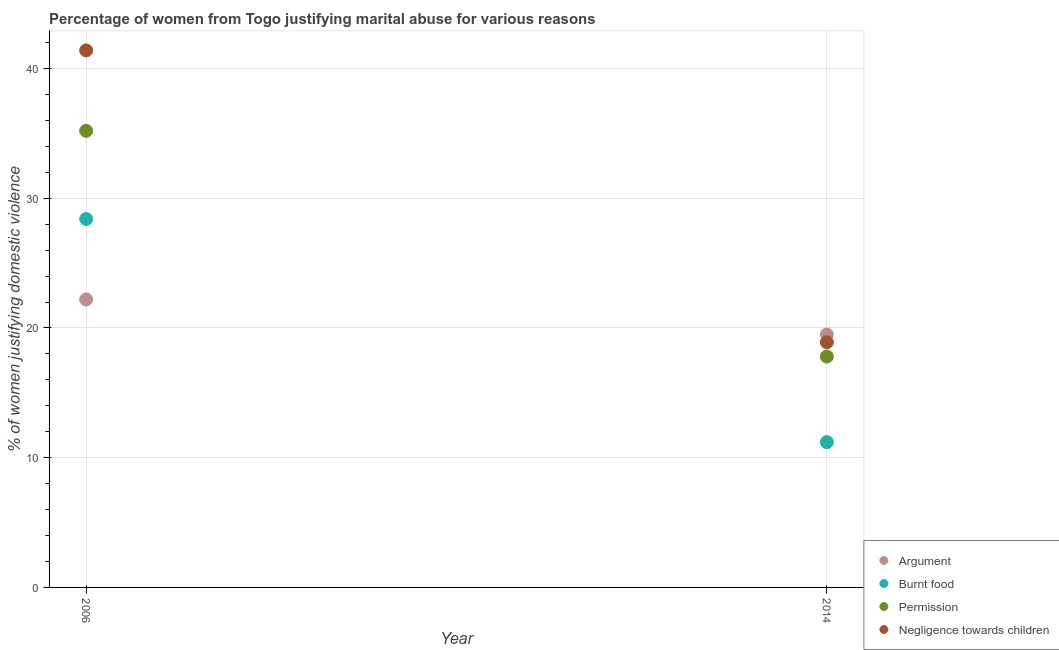How many different coloured dotlines are there?
Keep it short and to the point. 4. Is the number of dotlines equal to the number of legend labels?
Your answer should be very brief. Yes. Across all years, what is the minimum percentage of women justifying abuse for burning food?
Offer a terse response. 11.2. In which year was the percentage of women justifying abuse for burning food maximum?
Offer a terse response. 2006. What is the total percentage of women justifying abuse for burning food in the graph?
Offer a very short reply. 39.6. What is the difference between the percentage of women justifying abuse for burning food in 2006 and the percentage of women justifying abuse for showing negligence towards children in 2014?
Give a very brief answer. 9.5. What is the average percentage of women justifying abuse for burning food per year?
Your answer should be very brief. 19.8. In the year 2014, what is the difference between the percentage of women justifying abuse for going without permission and percentage of women justifying abuse for showing negligence towards children?
Offer a terse response. -1.1. In how many years, is the percentage of women justifying abuse for burning food greater than 6 %?
Provide a short and direct response. 2. What is the ratio of the percentage of women justifying abuse for showing negligence towards children in 2006 to that in 2014?
Your answer should be compact. 2.19. Is the percentage of women justifying abuse for showing negligence towards children in 2006 less than that in 2014?
Your response must be concise. No. In how many years, is the percentage of women justifying abuse for going without permission greater than the average percentage of women justifying abuse for going without permission taken over all years?
Your answer should be very brief. 1. Is it the case that in every year, the sum of the percentage of women justifying abuse in the case of an argument and percentage of women justifying abuse for burning food is greater than the percentage of women justifying abuse for going without permission?
Provide a short and direct response. Yes. Does the percentage of women justifying abuse for showing negligence towards children monotonically increase over the years?
Provide a succinct answer. No. Is the percentage of women justifying abuse for going without permission strictly greater than the percentage of women justifying abuse in the case of an argument over the years?
Keep it short and to the point. No. Is the percentage of women justifying abuse for burning food strictly less than the percentage of women justifying abuse in the case of an argument over the years?
Provide a succinct answer. No. How are the legend labels stacked?
Provide a short and direct response. Vertical. What is the title of the graph?
Provide a short and direct response. Percentage of women from Togo justifying marital abuse for various reasons. What is the label or title of the X-axis?
Offer a very short reply. Year. What is the label or title of the Y-axis?
Provide a succinct answer. % of women justifying domestic violence. What is the % of women justifying domestic violence in Argument in 2006?
Keep it short and to the point. 22.2. What is the % of women justifying domestic violence of Burnt food in 2006?
Provide a short and direct response. 28.4. What is the % of women justifying domestic violence of Permission in 2006?
Make the answer very short. 35.2. What is the % of women justifying domestic violence of Negligence towards children in 2006?
Offer a very short reply. 41.4. What is the % of women justifying domestic violence of Permission in 2014?
Your answer should be compact. 17.8. Across all years, what is the maximum % of women justifying domestic violence of Argument?
Give a very brief answer. 22.2. Across all years, what is the maximum % of women justifying domestic violence in Burnt food?
Make the answer very short. 28.4. Across all years, what is the maximum % of women justifying domestic violence of Permission?
Offer a very short reply. 35.2. Across all years, what is the maximum % of women justifying domestic violence in Negligence towards children?
Give a very brief answer. 41.4. Across all years, what is the minimum % of women justifying domestic violence of Permission?
Provide a short and direct response. 17.8. What is the total % of women justifying domestic violence of Argument in the graph?
Your answer should be compact. 41.7. What is the total % of women justifying domestic violence of Burnt food in the graph?
Provide a short and direct response. 39.6. What is the total % of women justifying domestic violence in Negligence towards children in the graph?
Keep it short and to the point. 60.3. What is the difference between the % of women justifying domestic violence of Burnt food in 2006 and that in 2014?
Provide a short and direct response. 17.2. What is the difference between the % of women justifying domestic violence of Permission in 2006 and that in 2014?
Offer a terse response. 17.4. What is the difference between the % of women justifying domestic violence of Negligence towards children in 2006 and that in 2014?
Your answer should be compact. 22.5. What is the difference between the % of women justifying domestic violence in Argument in 2006 and the % of women justifying domestic violence in Burnt food in 2014?
Offer a very short reply. 11. What is the difference between the % of women justifying domestic violence of Argument in 2006 and the % of women justifying domestic violence of Negligence towards children in 2014?
Offer a terse response. 3.3. What is the difference between the % of women justifying domestic violence of Burnt food in 2006 and the % of women justifying domestic violence of Permission in 2014?
Give a very brief answer. 10.6. What is the difference between the % of women justifying domestic violence in Permission in 2006 and the % of women justifying domestic violence in Negligence towards children in 2014?
Make the answer very short. 16.3. What is the average % of women justifying domestic violence of Argument per year?
Your response must be concise. 20.85. What is the average % of women justifying domestic violence in Burnt food per year?
Your answer should be compact. 19.8. What is the average % of women justifying domestic violence of Negligence towards children per year?
Give a very brief answer. 30.15. In the year 2006, what is the difference between the % of women justifying domestic violence in Argument and % of women justifying domestic violence in Burnt food?
Keep it short and to the point. -6.2. In the year 2006, what is the difference between the % of women justifying domestic violence of Argument and % of women justifying domestic violence of Negligence towards children?
Your answer should be very brief. -19.2. In the year 2014, what is the difference between the % of women justifying domestic violence of Argument and % of women justifying domestic violence of Permission?
Keep it short and to the point. 1.7. In the year 2014, what is the difference between the % of women justifying domestic violence of Burnt food and % of women justifying domestic violence of Negligence towards children?
Give a very brief answer. -7.7. What is the ratio of the % of women justifying domestic violence of Argument in 2006 to that in 2014?
Your answer should be compact. 1.14. What is the ratio of the % of women justifying domestic violence in Burnt food in 2006 to that in 2014?
Provide a succinct answer. 2.54. What is the ratio of the % of women justifying domestic violence of Permission in 2006 to that in 2014?
Keep it short and to the point. 1.98. What is the ratio of the % of women justifying domestic violence of Negligence towards children in 2006 to that in 2014?
Offer a terse response. 2.19. What is the difference between the highest and the second highest % of women justifying domestic violence of Argument?
Your response must be concise. 2.7. What is the difference between the highest and the second highest % of women justifying domestic violence of Burnt food?
Your answer should be compact. 17.2. What is the difference between the highest and the second highest % of women justifying domestic violence of Negligence towards children?
Offer a terse response. 22.5. What is the difference between the highest and the lowest % of women justifying domestic violence of Argument?
Your answer should be compact. 2.7. What is the difference between the highest and the lowest % of women justifying domestic violence in Burnt food?
Offer a terse response. 17.2. What is the difference between the highest and the lowest % of women justifying domestic violence in Permission?
Your response must be concise. 17.4. 